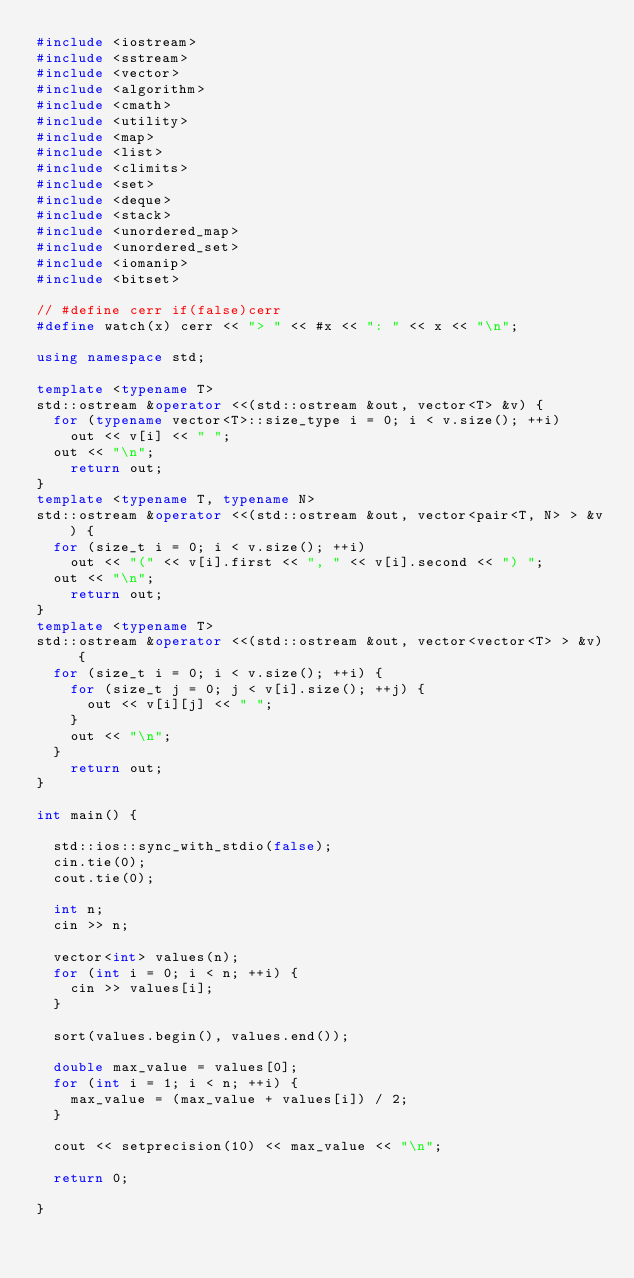Convert code to text. <code><loc_0><loc_0><loc_500><loc_500><_C++_>#include <iostream>
#include <sstream>
#include <vector>
#include <algorithm>
#include <cmath>
#include <utility>
#include <map>
#include <list>
#include <climits>
#include <set>
#include <deque>
#include <stack>
#include <unordered_map>
#include <unordered_set>
#include <iomanip>
#include <bitset>

// #define cerr if(false)cerr
#define watch(x) cerr << "> " << #x << ": " << x << "\n";

using namespace std;

template <typename T>
std::ostream &operator <<(std::ostream &out, vector<T> &v) {
	for (typename vector<T>::size_type i = 0; i < v.size(); ++i)
		out << v[i] << " ";
	out << "\n";
    return out;
}
template <typename T, typename N>
std::ostream &operator <<(std::ostream &out, vector<pair<T, N> > &v) {
	for (size_t i = 0; i < v.size(); ++i)
		out << "(" << v[i].first << ", " << v[i].second << ") ";
	out << "\n";
    return out;
}
template <typename T>
std::ostream &operator <<(std::ostream &out, vector<vector<T> > &v) {
	for (size_t i = 0; i < v.size(); ++i) {
		for (size_t j = 0; j < v[i].size(); ++j) {
			out << v[i][j] << " ";
		}
		out << "\n";
	}
   	return out;
}

int main() {

	std::ios::sync_with_stdio(false);
	cin.tie(0);
	cout.tie(0);

	int n;
	cin >> n;

	vector<int> values(n);
	for (int i = 0; i < n; ++i) {
		cin >> values[i];
	}

	sort(values.begin(), values.end());

	double max_value = values[0];
	for (int i = 1; i < n; ++i) {
		max_value = (max_value + values[i]) / 2;
	}

	cout << setprecision(10) << max_value << "\n";

	return 0;

}</code> 